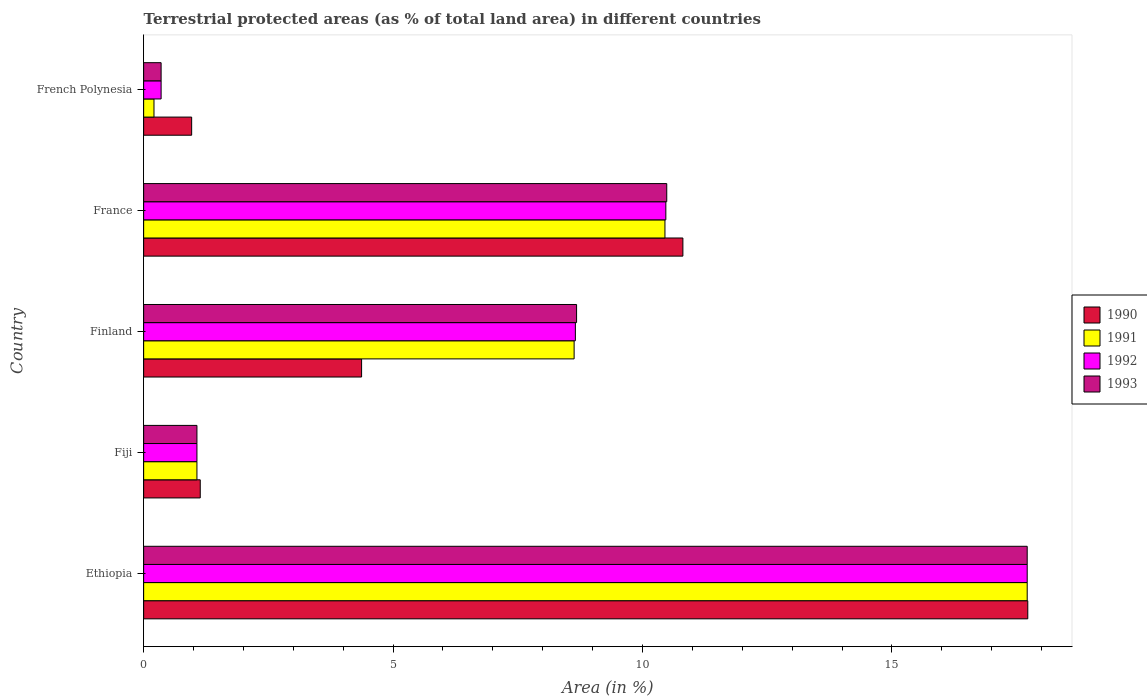How many bars are there on the 1st tick from the top?
Offer a terse response. 4. How many bars are there on the 1st tick from the bottom?
Provide a succinct answer. 4. What is the label of the 1st group of bars from the top?
Offer a very short reply. French Polynesia. What is the percentage of terrestrial protected land in 1993 in France?
Provide a succinct answer. 10.49. Across all countries, what is the maximum percentage of terrestrial protected land in 1990?
Offer a terse response. 17.72. Across all countries, what is the minimum percentage of terrestrial protected land in 1992?
Give a very brief answer. 0.35. In which country was the percentage of terrestrial protected land in 1992 maximum?
Provide a short and direct response. Ethiopia. In which country was the percentage of terrestrial protected land in 1993 minimum?
Your response must be concise. French Polynesia. What is the total percentage of terrestrial protected land in 1993 in the graph?
Provide a succinct answer. 38.29. What is the difference between the percentage of terrestrial protected land in 1992 in Ethiopia and that in France?
Keep it short and to the point. 7.24. What is the difference between the percentage of terrestrial protected land in 1992 in Fiji and the percentage of terrestrial protected land in 1990 in Finland?
Keep it short and to the point. -3.3. What is the average percentage of terrestrial protected land in 1992 per country?
Ensure brevity in your answer.  7.65. What is the difference between the percentage of terrestrial protected land in 1992 and percentage of terrestrial protected land in 1990 in French Polynesia?
Give a very brief answer. -0.61. In how many countries, is the percentage of terrestrial protected land in 1990 greater than 7 %?
Ensure brevity in your answer.  2. What is the ratio of the percentage of terrestrial protected land in 1991 in Finland to that in France?
Provide a short and direct response. 0.83. What is the difference between the highest and the second highest percentage of terrestrial protected land in 1993?
Provide a short and direct response. 7.23. What is the difference between the highest and the lowest percentage of terrestrial protected land in 1991?
Ensure brevity in your answer.  17.5. Is the sum of the percentage of terrestrial protected land in 1992 in Finland and French Polynesia greater than the maximum percentage of terrestrial protected land in 1991 across all countries?
Keep it short and to the point. No. Is it the case that in every country, the sum of the percentage of terrestrial protected land in 1990 and percentage of terrestrial protected land in 1992 is greater than the sum of percentage of terrestrial protected land in 1993 and percentage of terrestrial protected land in 1991?
Your response must be concise. No. What does the 4th bar from the top in Finland represents?
Your answer should be compact. 1990. What does the 4th bar from the bottom in Fiji represents?
Your answer should be very brief. 1993. Are all the bars in the graph horizontal?
Your response must be concise. Yes. How many countries are there in the graph?
Offer a very short reply. 5. Are the values on the major ticks of X-axis written in scientific E-notation?
Keep it short and to the point. No. How many legend labels are there?
Make the answer very short. 4. What is the title of the graph?
Offer a very short reply. Terrestrial protected areas (as % of total land area) in different countries. Does "2010" appear as one of the legend labels in the graph?
Your answer should be compact. No. What is the label or title of the X-axis?
Your response must be concise. Area (in %). What is the Area (in %) of 1990 in Ethiopia?
Make the answer very short. 17.72. What is the Area (in %) in 1991 in Ethiopia?
Provide a short and direct response. 17.71. What is the Area (in %) of 1992 in Ethiopia?
Offer a terse response. 17.71. What is the Area (in %) of 1993 in Ethiopia?
Your answer should be very brief. 17.71. What is the Area (in %) of 1990 in Fiji?
Provide a succinct answer. 1.13. What is the Area (in %) in 1991 in Fiji?
Keep it short and to the point. 1.07. What is the Area (in %) in 1992 in Fiji?
Provide a short and direct response. 1.07. What is the Area (in %) of 1993 in Fiji?
Your answer should be very brief. 1.07. What is the Area (in %) of 1990 in Finland?
Your answer should be very brief. 4.37. What is the Area (in %) in 1991 in Finland?
Your response must be concise. 8.63. What is the Area (in %) in 1992 in Finland?
Provide a short and direct response. 8.65. What is the Area (in %) in 1993 in Finland?
Make the answer very short. 8.68. What is the Area (in %) in 1990 in France?
Your response must be concise. 10.81. What is the Area (in %) in 1991 in France?
Your answer should be compact. 10.45. What is the Area (in %) in 1992 in France?
Offer a terse response. 10.47. What is the Area (in %) of 1993 in France?
Provide a short and direct response. 10.49. What is the Area (in %) of 1990 in French Polynesia?
Offer a very short reply. 0.96. What is the Area (in %) of 1991 in French Polynesia?
Provide a succinct answer. 0.21. What is the Area (in %) of 1992 in French Polynesia?
Keep it short and to the point. 0.35. What is the Area (in %) of 1993 in French Polynesia?
Provide a short and direct response. 0.35. Across all countries, what is the maximum Area (in %) of 1990?
Make the answer very short. 17.72. Across all countries, what is the maximum Area (in %) of 1991?
Provide a succinct answer. 17.71. Across all countries, what is the maximum Area (in %) in 1992?
Keep it short and to the point. 17.71. Across all countries, what is the maximum Area (in %) of 1993?
Ensure brevity in your answer.  17.71. Across all countries, what is the minimum Area (in %) of 1990?
Ensure brevity in your answer.  0.96. Across all countries, what is the minimum Area (in %) in 1991?
Your answer should be compact. 0.21. Across all countries, what is the minimum Area (in %) of 1992?
Offer a terse response. 0.35. Across all countries, what is the minimum Area (in %) of 1993?
Offer a terse response. 0.35. What is the total Area (in %) in 1990 in the graph?
Your answer should be compact. 35. What is the total Area (in %) in 1991 in the graph?
Give a very brief answer. 38.06. What is the total Area (in %) in 1992 in the graph?
Offer a very short reply. 38.25. What is the total Area (in %) in 1993 in the graph?
Make the answer very short. 38.29. What is the difference between the Area (in %) in 1990 in Ethiopia and that in Fiji?
Keep it short and to the point. 16.59. What is the difference between the Area (in %) of 1991 in Ethiopia and that in Fiji?
Give a very brief answer. 16.64. What is the difference between the Area (in %) of 1992 in Ethiopia and that in Fiji?
Ensure brevity in your answer.  16.64. What is the difference between the Area (in %) of 1993 in Ethiopia and that in Fiji?
Give a very brief answer. 16.64. What is the difference between the Area (in %) of 1990 in Ethiopia and that in Finland?
Give a very brief answer. 13.35. What is the difference between the Area (in %) in 1991 in Ethiopia and that in Finland?
Offer a very short reply. 9.08. What is the difference between the Area (in %) in 1992 in Ethiopia and that in Finland?
Your answer should be compact. 9.06. What is the difference between the Area (in %) of 1993 in Ethiopia and that in Finland?
Your answer should be compact. 9.03. What is the difference between the Area (in %) of 1990 in Ethiopia and that in France?
Provide a succinct answer. 6.91. What is the difference between the Area (in %) of 1991 in Ethiopia and that in France?
Give a very brief answer. 7.26. What is the difference between the Area (in %) in 1992 in Ethiopia and that in France?
Provide a short and direct response. 7.24. What is the difference between the Area (in %) in 1993 in Ethiopia and that in France?
Give a very brief answer. 7.23. What is the difference between the Area (in %) of 1990 in Ethiopia and that in French Polynesia?
Give a very brief answer. 16.76. What is the difference between the Area (in %) of 1991 in Ethiopia and that in French Polynesia?
Offer a terse response. 17.5. What is the difference between the Area (in %) of 1992 in Ethiopia and that in French Polynesia?
Your response must be concise. 17.36. What is the difference between the Area (in %) in 1993 in Ethiopia and that in French Polynesia?
Your answer should be compact. 17.36. What is the difference between the Area (in %) in 1990 in Fiji and that in Finland?
Offer a very short reply. -3.23. What is the difference between the Area (in %) in 1991 in Fiji and that in Finland?
Offer a terse response. -7.56. What is the difference between the Area (in %) in 1992 in Fiji and that in Finland?
Your answer should be compact. -7.59. What is the difference between the Area (in %) in 1993 in Fiji and that in Finland?
Offer a very short reply. -7.61. What is the difference between the Area (in %) in 1990 in Fiji and that in France?
Keep it short and to the point. -9.67. What is the difference between the Area (in %) of 1991 in Fiji and that in France?
Provide a short and direct response. -9.38. What is the difference between the Area (in %) of 1992 in Fiji and that in France?
Your answer should be very brief. -9.4. What is the difference between the Area (in %) in 1993 in Fiji and that in France?
Provide a short and direct response. -9.42. What is the difference between the Area (in %) of 1990 in Fiji and that in French Polynesia?
Make the answer very short. 0.17. What is the difference between the Area (in %) of 1991 in Fiji and that in French Polynesia?
Your answer should be very brief. 0.86. What is the difference between the Area (in %) in 1992 in Fiji and that in French Polynesia?
Offer a terse response. 0.72. What is the difference between the Area (in %) in 1993 in Fiji and that in French Polynesia?
Offer a very short reply. 0.72. What is the difference between the Area (in %) in 1990 in Finland and that in France?
Your response must be concise. -6.44. What is the difference between the Area (in %) in 1991 in Finland and that in France?
Keep it short and to the point. -1.82. What is the difference between the Area (in %) in 1992 in Finland and that in France?
Keep it short and to the point. -1.81. What is the difference between the Area (in %) of 1993 in Finland and that in France?
Provide a short and direct response. -1.81. What is the difference between the Area (in %) of 1990 in Finland and that in French Polynesia?
Offer a very short reply. 3.41. What is the difference between the Area (in %) in 1991 in Finland and that in French Polynesia?
Your answer should be very brief. 8.42. What is the difference between the Area (in %) in 1992 in Finland and that in French Polynesia?
Make the answer very short. 8.3. What is the difference between the Area (in %) in 1993 in Finland and that in French Polynesia?
Your response must be concise. 8.33. What is the difference between the Area (in %) of 1990 in France and that in French Polynesia?
Provide a succinct answer. 9.85. What is the difference between the Area (in %) in 1991 in France and that in French Polynesia?
Ensure brevity in your answer.  10.24. What is the difference between the Area (in %) of 1992 in France and that in French Polynesia?
Keep it short and to the point. 10.12. What is the difference between the Area (in %) of 1993 in France and that in French Polynesia?
Your response must be concise. 10.14. What is the difference between the Area (in %) of 1990 in Ethiopia and the Area (in %) of 1991 in Fiji?
Offer a very short reply. 16.65. What is the difference between the Area (in %) in 1990 in Ethiopia and the Area (in %) in 1992 in Fiji?
Offer a terse response. 16.65. What is the difference between the Area (in %) of 1990 in Ethiopia and the Area (in %) of 1993 in Fiji?
Keep it short and to the point. 16.65. What is the difference between the Area (in %) in 1991 in Ethiopia and the Area (in %) in 1992 in Fiji?
Offer a very short reply. 16.64. What is the difference between the Area (in %) of 1991 in Ethiopia and the Area (in %) of 1993 in Fiji?
Keep it short and to the point. 16.64. What is the difference between the Area (in %) of 1992 in Ethiopia and the Area (in %) of 1993 in Fiji?
Keep it short and to the point. 16.64. What is the difference between the Area (in %) of 1990 in Ethiopia and the Area (in %) of 1991 in Finland?
Keep it short and to the point. 9.09. What is the difference between the Area (in %) of 1990 in Ethiopia and the Area (in %) of 1992 in Finland?
Keep it short and to the point. 9.07. What is the difference between the Area (in %) of 1990 in Ethiopia and the Area (in %) of 1993 in Finland?
Your answer should be very brief. 9.04. What is the difference between the Area (in %) in 1991 in Ethiopia and the Area (in %) in 1992 in Finland?
Provide a succinct answer. 9.06. What is the difference between the Area (in %) in 1991 in Ethiopia and the Area (in %) in 1993 in Finland?
Your response must be concise. 9.03. What is the difference between the Area (in %) in 1992 in Ethiopia and the Area (in %) in 1993 in Finland?
Offer a very short reply. 9.03. What is the difference between the Area (in %) of 1990 in Ethiopia and the Area (in %) of 1991 in France?
Make the answer very short. 7.27. What is the difference between the Area (in %) in 1990 in Ethiopia and the Area (in %) in 1992 in France?
Your answer should be very brief. 7.26. What is the difference between the Area (in %) in 1990 in Ethiopia and the Area (in %) in 1993 in France?
Your answer should be very brief. 7.24. What is the difference between the Area (in %) of 1991 in Ethiopia and the Area (in %) of 1992 in France?
Your response must be concise. 7.24. What is the difference between the Area (in %) in 1991 in Ethiopia and the Area (in %) in 1993 in France?
Your answer should be very brief. 7.23. What is the difference between the Area (in %) in 1992 in Ethiopia and the Area (in %) in 1993 in France?
Offer a very short reply. 7.23. What is the difference between the Area (in %) of 1990 in Ethiopia and the Area (in %) of 1991 in French Polynesia?
Your response must be concise. 17.52. What is the difference between the Area (in %) of 1990 in Ethiopia and the Area (in %) of 1992 in French Polynesia?
Ensure brevity in your answer.  17.37. What is the difference between the Area (in %) of 1990 in Ethiopia and the Area (in %) of 1993 in French Polynesia?
Your answer should be compact. 17.37. What is the difference between the Area (in %) of 1991 in Ethiopia and the Area (in %) of 1992 in French Polynesia?
Offer a very short reply. 17.36. What is the difference between the Area (in %) of 1991 in Ethiopia and the Area (in %) of 1993 in French Polynesia?
Offer a very short reply. 17.36. What is the difference between the Area (in %) of 1992 in Ethiopia and the Area (in %) of 1993 in French Polynesia?
Give a very brief answer. 17.36. What is the difference between the Area (in %) in 1990 in Fiji and the Area (in %) in 1991 in Finland?
Offer a very short reply. -7.49. What is the difference between the Area (in %) of 1990 in Fiji and the Area (in %) of 1992 in Finland?
Your answer should be compact. -7.52. What is the difference between the Area (in %) of 1990 in Fiji and the Area (in %) of 1993 in Finland?
Your answer should be compact. -7.54. What is the difference between the Area (in %) of 1991 in Fiji and the Area (in %) of 1992 in Finland?
Offer a very short reply. -7.59. What is the difference between the Area (in %) of 1991 in Fiji and the Area (in %) of 1993 in Finland?
Offer a very short reply. -7.61. What is the difference between the Area (in %) of 1992 in Fiji and the Area (in %) of 1993 in Finland?
Make the answer very short. -7.61. What is the difference between the Area (in %) in 1990 in Fiji and the Area (in %) in 1991 in France?
Offer a very short reply. -9.32. What is the difference between the Area (in %) of 1990 in Fiji and the Area (in %) of 1992 in France?
Keep it short and to the point. -9.33. What is the difference between the Area (in %) of 1990 in Fiji and the Area (in %) of 1993 in France?
Keep it short and to the point. -9.35. What is the difference between the Area (in %) in 1991 in Fiji and the Area (in %) in 1992 in France?
Your answer should be compact. -9.4. What is the difference between the Area (in %) in 1991 in Fiji and the Area (in %) in 1993 in France?
Ensure brevity in your answer.  -9.42. What is the difference between the Area (in %) in 1992 in Fiji and the Area (in %) in 1993 in France?
Give a very brief answer. -9.42. What is the difference between the Area (in %) of 1990 in Fiji and the Area (in %) of 1991 in French Polynesia?
Provide a succinct answer. 0.93. What is the difference between the Area (in %) of 1990 in Fiji and the Area (in %) of 1992 in French Polynesia?
Keep it short and to the point. 0.78. What is the difference between the Area (in %) in 1990 in Fiji and the Area (in %) in 1993 in French Polynesia?
Keep it short and to the point. 0.78. What is the difference between the Area (in %) of 1991 in Fiji and the Area (in %) of 1992 in French Polynesia?
Your answer should be compact. 0.72. What is the difference between the Area (in %) of 1991 in Fiji and the Area (in %) of 1993 in French Polynesia?
Make the answer very short. 0.72. What is the difference between the Area (in %) in 1992 in Fiji and the Area (in %) in 1993 in French Polynesia?
Offer a terse response. 0.72. What is the difference between the Area (in %) of 1990 in Finland and the Area (in %) of 1991 in France?
Provide a succinct answer. -6.08. What is the difference between the Area (in %) of 1990 in Finland and the Area (in %) of 1992 in France?
Provide a short and direct response. -6.1. What is the difference between the Area (in %) in 1990 in Finland and the Area (in %) in 1993 in France?
Offer a very short reply. -6.12. What is the difference between the Area (in %) in 1991 in Finland and the Area (in %) in 1992 in France?
Offer a terse response. -1.84. What is the difference between the Area (in %) in 1991 in Finland and the Area (in %) in 1993 in France?
Your response must be concise. -1.86. What is the difference between the Area (in %) of 1992 in Finland and the Area (in %) of 1993 in France?
Ensure brevity in your answer.  -1.83. What is the difference between the Area (in %) in 1990 in Finland and the Area (in %) in 1991 in French Polynesia?
Your answer should be compact. 4.16. What is the difference between the Area (in %) in 1990 in Finland and the Area (in %) in 1992 in French Polynesia?
Make the answer very short. 4.02. What is the difference between the Area (in %) in 1990 in Finland and the Area (in %) in 1993 in French Polynesia?
Provide a succinct answer. 4.02. What is the difference between the Area (in %) of 1991 in Finland and the Area (in %) of 1992 in French Polynesia?
Keep it short and to the point. 8.28. What is the difference between the Area (in %) in 1991 in Finland and the Area (in %) in 1993 in French Polynesia?
Provide a succinct answer. 8.28. What is the difference between the Area (in %) in 1992 in Finland and the Area (in %) in 1993 in French Polynesia?
Offer a terse response. 8.3. What is the difference between the Area (in %) in 1990 in France and the Area (in %) in 1991 in French Polynesia?
Provide a short and direct response. 10.6. What is the difference between the Area (in %) of 1990 in France and the Area (in %) of 1992 in French Polynesia?
Make the answer very short. 10.46. What is the difference between the Area (in %) in 1990 in France and the Area (in %) in 1993 in French Polynesia?
Provide a short and direct response. 10.46. What is the difference between the Area (in %) of 1991 in France and the Area (in %) of 1992 in French Polynesia?
Your response must be concise. 10.1. What is the difference between the Area (in %) of 1991 in France and the Area (in %) of 1993 in French Polynesia?
Give a very brief answer. 10.1. What is the difference between the Area (in %) of 1992 in France and the Area (in %) of 1993 in French Polynesia?
Provide a succinct answer. 10.12. What is the average Area (in %) of 1990 per country?
Your answer should be very brief. 7. What is the average Area (in %) in 1991 per country?
Provide a succinct answer. 7.61. What is the average Area (in %) of 1992 per country?
Make the answer very short. 7.65. What is the average Area (in %) in 1993 per country?
Offer a very short reply. 7.66. What is the difference between the Area (in %) in 1990 and Area (in %) in 1991 in Ethiopia?
Your answer should be compact. 0.01. What is the difference between the Area (in %) of 1990 and Area (in %) of 1992 in Ethiopia?
Provide a short and direct response. 0.01. What is the difference between the Area (in %) in 1990 and Area (in %) in 1993 in Ethiopia?
Give a very brief answer. 0.01. What is the difference between the Area (in %) in 1991 and Area (in %) in 1992 in Ethiopia?
Provide a succinct answer. 0. What is the difference between the Area (in %) in 1991 and Area (in %) in 1993 in Ethiopia?
Give a very brief answer. 0. What is the difference between the Area (in %) in 1990 and Area (in %) in 1991 in Fiji?
Your answer should be compact. 0.07. What is the difference between the Area (in %) of 1990 and Area (in %) of 1992 in Fiji?
Your answer should be compact. 0.07. What is the difference between the Area (in %) of 1990 and Area (in %) of 1993 in Fiji?
Ensure brevity in your answer.  0.07. What is the difference between the Area (in %) in 1991 and Area (in %) in 1992 in Fiji?
Keep it short and to the point. 0. What is the difference between the Area (in %) of 1991 and Area (in %) of 1993 in Fiji?
Offer a terse response. 0. What is the difference between the Area (in %) in 1990 and Area (in %) in 1991 in Finland?
Your answer should be compact. -4.26. What is the difference between the Area (in %) in 1990 and Area (in %) in 1992 in Finland?
Provide a short and direct response. -4.29. What is the difference between the Area (in %) of 1990 and Area (in %) of 1993 in Finland?
Offer a very short reply. -4.31. What is the difference between the Area (in %) in 1991 and Area (in %) in 1992 in Finland?
Offer a very short reply. -0.03. What is the difference between the Area (in %) of 1991 and Area (in %) of 1993 in Finland?
Make the answer very short. -0.05. What is the difference between the Area (in %) of 1992 and Area (in %) of 1993 in Finland?
Offer a terse response. -0.02. What is the difference between the Area (in %) in 1990 and Area (in %) in 1991 in France?
Provide a succinct answer. 0.36. What is the difference between the Area (in %) in 1990 and Area (in %) in 1992 in France?
Provide a short and direct response. 0.34. What is the difference between the Area (in %) of 1990 and Area (in %) of 1993 in France?
Ensure brevity in your answer.  0.32. What is the difference between the Area (in %) in 1991 and Area (in %) in 1992 in France?
Provide a short and direct response. -0.02. What is the difference between the Area (in %) of 1991 and Area (in %) of 1993 in France?
Your answer should be compact. -0.04. What is the difference between the Area (in %) of 1992 and Area (in %) of 1993 in France?
Provide a succinct answer. -0.02. What is the difference between the Area (in %) in 1990 and Area (in %) in 1991 in French Polynesia?
Keep it short and to the point. 0.76. What is the difference between the Area (in %) of 1990 and Area (in %) of 1992 in French Polynesia?
Give a very brief answer. 0.61. What is the difference between the Area (in %) of 1990 and Area (in %) of 1993 in French Polynesia?
Give a very brief answer. 0.61. What is the difference between the Area (in %) in 1991 and Area (in %) in 1992 in French Polynesia?
Provide a short and direct response. -0.14. What is the difference between the Area (in %) in 1991 and Area (in %) in 1993 in French Polynesia?
Make the answer very short. -0.14. What is the ratio of the Area (in %) of 1990 in Ethiopia to that in Fiji?
Provide a short and direct response. 15.62. What is the ratio of the Area (in %) in 1991 in Ethiopia to that in Fiji?
Your answer should be very brief. 16.58. What is the ratio of the Area (in %) in 1992 in Ethiopia to that in Fiji?
Keep it short and to the point. 16.58. What is the ratio of the Area (in %) in 1993 in Ethiopia to that in Fiji?
Your answer should be very brief. 16.58. What is the ratio of the Area (in %) of 1990 in Ethiopia to that in Finland?
Your answer should be very brief. 4.06. What is the ratio of the Area (in %) of 1991 in Ethiopia to that in Finland?
Provide a succinct answer. 2.05. What is the ratio of the Area (in %) in 1992 in Ethiopia to that in Finland?
Provide a succinct answer. 2.05. What is the ratio of the Area (in %) in 1993 in Ethiopia to that in Finland?
Offer a very short reply. 2.04. What is the ratio of the Area (in %) in 1990 in Ethiopia to that in France?
Offer a terse response. 1.64. What is the ratio of the Area (in %) in 1991 in Ethiopia to that in France?
Give a very brief answer. 1.69. What is the ratio of the Area (in %) of 1992 in Ethiopia to that in France?
Your answer should be very brief. 1.69. What is the ratio of the Area (in %) of 1993 in Ethiopia to that in France?
Give a very brief answer. 1.69. What is the ratio of the Area (in %) in 1990 in Ethiopia to that in French Polynesia?
Provide a short and direct response. 18.42. What is the ratio of the Area (in %) of 1991 in Ethiopia to that in French Polynesia?
Ensure brevity in your answer.  85.45. What is the ratio of the Area (in %) of 1992 in Ethiopia to that in French Polynesia?
Keep it short and to the point. 50.59. What is the ratio of the Area (in %) in 1993 in Ethiopia to that in French Polynesia?
Offer a terse response. 50.59. What is the ratio of the Area (in %) in 1990 in Fiji to that in Finland?
Provide a succinct answer. 0.26. What is the ratio of the Area (in %) in 1991 in Fiji to that in Finland?
Your answer should be compact. 0.12. What is the ratio of the Area (in %) in 1992 in Fiji to that in Finland?
Your answer should be compact. 0.12. What is the ratio of the Area (in %) of 1993 in Fiji to that in Finland?
Give a very brief answer. 0.12. What is the ratio of the Area (in %) in 1990 in Fiji to that in France?
Provide a short and direct response. 0.1. What is the ratio of the Area (in %) of 1991 in Fiji to that in France?
Offer a very short reply. 0.1. What is the ratio of the Area (in %) in 1992 in Fiji to that in France?
Keep it short and to the point. 0.1. What is the ratio of the Area (in %) in 1993 in Fiji to that in France?
Offer a terse response. 0.1. What is the ratio of the Area (in %) in 1990 in Fiji to that in French Polynesia?
Offer a very short reply. 1.18. What is the ratio of the Area (in %) of 1991 in Fiji to that in French Polynesia?
Your answer should be compact. 5.15. What is the ratio of the Area (in %) in 1992 in Fiji to that in French Polynesia?
Give a very brief answer. 3.05. What is the ratio of the Area (in %) in 1993 in Fiji to that in French Polynesia?
Provide a short and direct response. 3.05. What is the ratio of the Area (in %) of 1990 in Finland to that in France?
Give a very brief answer. 0.4. What is the ratio of the Area (in %) of 1991 in Finland to that in France?
Your answer should be compact. 0.83. What is the ratio of the Area (in %) of 1992 in Finland to that in France?
Your answer should be very brief. 0.83. What is the ratio of the Area (in %) of 1993 in Finland to that in France?
Your answer should be compact. 0.83. What is the ratio of the Area (in %) in 1990 in Finland to that in French Polynesia?
Provide a succinct answer. 4.54. What is the ratio of the Area (in %) of 1991 in Finland to that in French Polynesia?
Your answer should be very brief. 41.63. What is the ratio of the Area (in %) of 1992 in Finland to that in French Polynesia?
Provide a short and direct response. 24.72. What is the ratio of the Area (in %) in 1993 in Finland to that in French Polynesia?
Ensure brevity in your answer.  24.79. What is the ratio of the Area (in %) in 1990 in France to that in French Polynesia?
Your answer should be compact. 11.23. What is the ratio of the Area (in %) in 1991 in France to that in French Polynesia?
Make the answer very short. 50.42. What is the ratio of the Area (in %) of 1992 in France to that in French Polynesia?
Offer a terse response. 29.9. What is the ratio of the Area (in %) of 1993 in France to that in French Polynesia?
Your answer should be compact. 29.95. What is the difference between the highest and the second highest Area (in %) of 1990?
Your response must be concise. 6.91. What is the difference between the highest and the second highest Area (in %) in 1991?
Make the answer very short. 7.26. What is the difference between the highest and the second highest Area (in %) in 1992?
Keep it short and to the point. 7.24. What is the difference between the highest and the second highest Area (in %) of 1993?
Make the answer very short. 7.23. What is the difference between the highest and the lowest Area (in %) of 1990?
Ensure brevity in your answer.  16.76. What is the difference between the highest and the lowest Area (in %) in 1991?
Make the answer very short. 17.5. What is the difference between the highest and the lowest Area (in %) of 1992?
Make the answer very short. 17.36. What is the difference between the highest and the lowest Area (in %) of 1993?
Give a very brief answer. 17.36. 